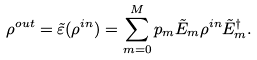Convert formula to latex. <formula><loc_0><loc_0><loc_500><loc_500>\rho ^ { o u t } = \tilde { \varepsilon } ( \rho ^ { i n } ) = \sum _ { m = 0 } ^ { M } p _ { m } \tilde { E } _ { m } \rho ^ { i n } \tilde { E } _ { m } ^ { \dagger } .</formula> 